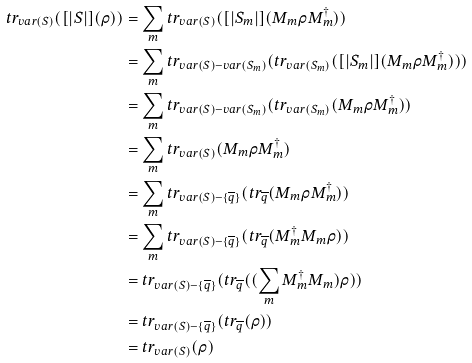<formula> <loc_0><loc_0><loc_500><loc_500>t r _ { v a r ( S ) } ( [ | S | ] ( \rho ) ) & = \sum _ { m } t r _ { v a r ( S ) } ( [ | S _ { m } | ] ( M _ { m } \rho M _ { m } ^ { \dag } ) ) \\ & = \sum _ { m } t r _ { v a r ( S ) - v a r ( S _ { m } ) } ( t r _ { v a r ( S _ { m } ) } ( [ | S _ { m } | ] ( M _ { m } \rho M _ { m } ^ { \dag } ) ) ) \\ & = \sum _ { m } t r _ { v a r ( S ) - v a r ( S _ { m } ) } ( t r _ { v a r ( S _ { m } ) } ( M _ { m } \rho M _ { m } ^ { \dag } ) ) \\ & = \sum _ { m } t r _ { v a r ( S ) } ( M _ { m } \rho M _ { m } ^ { \dag } ) \\ & = \sum _ { m } t r _ { v a r ( S ) - \{ \overline { q } \} } ( t r _ { \overline { q } } ( M _ { m } \rho M _ { m } ^ { \dag } ) ) \\ & = \sum _ { m } t r _ { v a r ( S ) - \{ \overline { q } \} } ( t r _ { \overline { q } } ( M _ { m } ^ { \dag } M _ { m } \rho ) ) \\ & = t r _ { v a r ( S ) - \{ \overline { q } \} } ( t r _ { \overline { q } } ( ( \sum _ { m } M _ { m } ^ { \dag } M _ { m } ) \rho ) ) \\ & = t r _ { v a r ( S ) - \{ \overline { q } \} } ( t r _ { \overline { q } } ( \rho ) ) \\ & = t r _ { v a r ( S ) } ( \rho )</formula> 